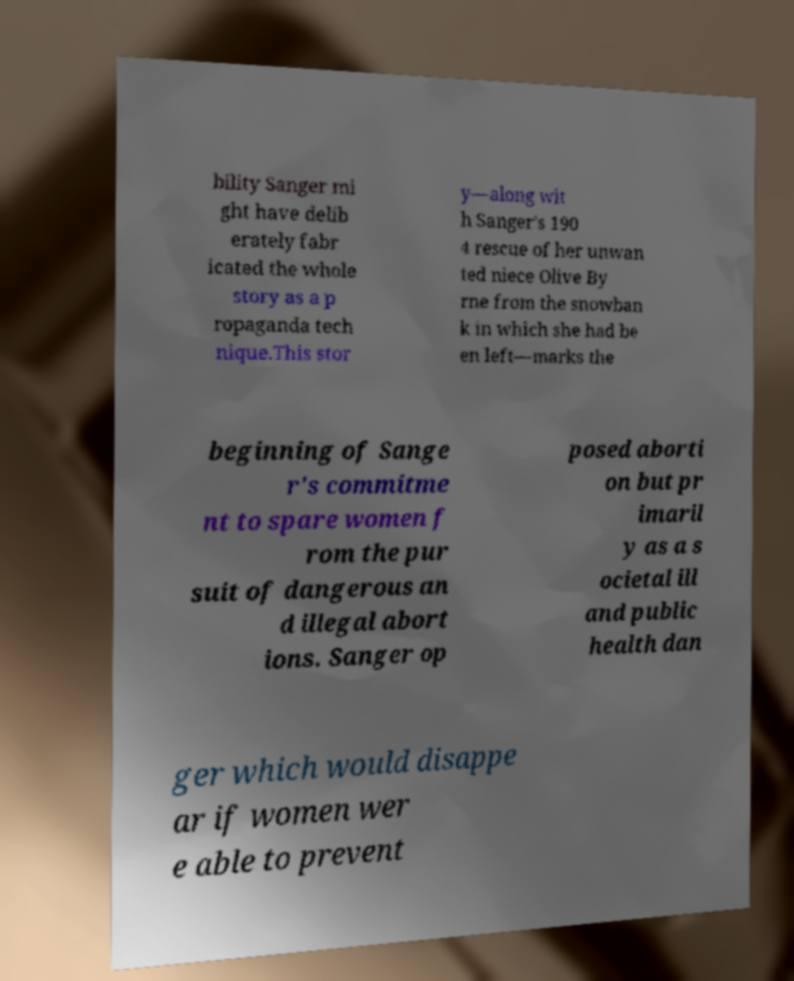For documentation purposes, I need the text within this image transcribed. Could you provide that? bility Sanger mi ght have delib erately fabr icated the whole story as a p ropaganda tech nique.This stor y—along wit h Sanger's 190 4 rescue of her unwan ted niece Olive By rne from the snowban k in which she had be en left—marks the beginning of Sange r's commitme nt to spare women f rom the pur suit of dangerous an d illegal abort ions. Sanger op posed aborti on but pr imaril y as a s ocietal ill and public health dan ger which would disappe ar if women wer e able to prevent 